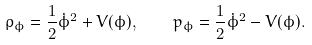<formula> <loc_0><loc_0><loc_500><loc_500>\rho _ { \phi } = \frac { 1 } { 2 } \dot { \phi } ^ { 2 } + V ( \phi ) , \quad p _ { \phi } = \frac { 1 } { 2 } \dot { \phi } ^ { 2 } - V ( \phi ) .</formula> 